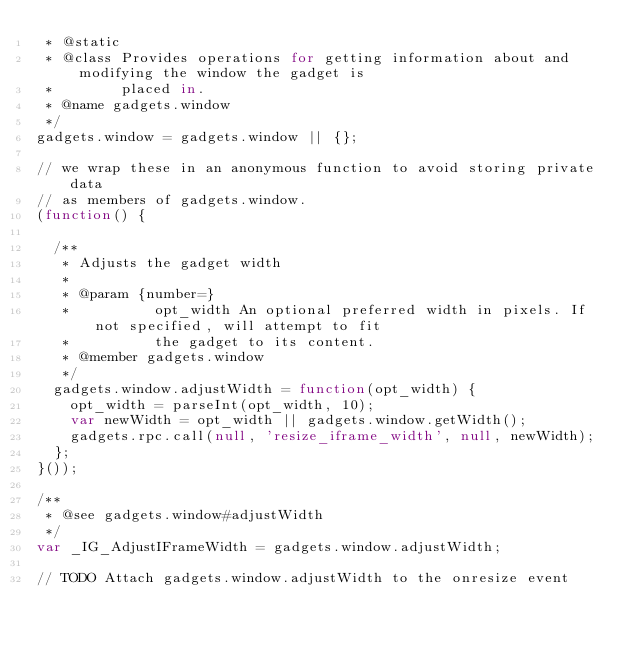Convert code to text. <code><loc_0><loc_0><loc_500><loc_500><_JavaScript_> * @static
 * @class Provides operations for getting information about and modifying the window the gadget is
 *        placed in.
 * @name gadgets.window
 */
gadgets.window = gadgets.window || {};

// we wrap these in an anonymous function to avoid storing private data
// as members of gadgets.window.
(function() {

  /**
   * Adjusts the gadget width
   *
   * @param {number=}
   *          opt_width An optional preferred width in pixels. If not specified, will attempt to fit
   *          the gadget to its content.
   * @member gadgets.window
   */
  gadgets.window.adjustWidth = function(opt_width) {
    opt_width = parseInt(opt_width, 10);
    var newWidth = opt_width || gadgets.window.getWidth();
    gadgets.rpc.call(null, 'resize_iframe_width', null, newWidth);
  };
}());

/**
 * @see gadgets.window#adjustWidth
 */
var _IG_AdjustIFrameWidth = gadgets.window.adjustWidth;

// TODO Attach gadgets.window.adjustWidth to the onresize event
</code> 